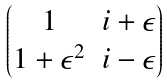<formula> <loc_0><loc_0><loc_500><loc_500>\begin{pmatrix} 1 & i + \epsilon \\ 1 + \epsilon ^ { 2 } & i - \epsilon \end{pmatrix}</formula> 